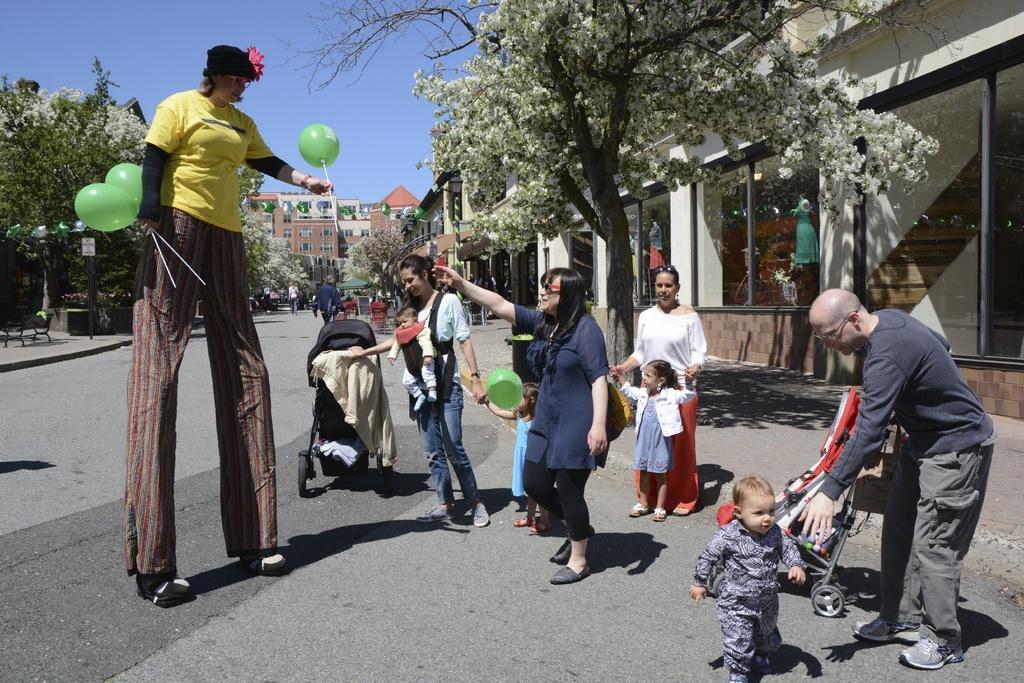In one or two sentences, can you explain what this image depicts? In this image I can see group of people, some are standing and some are walking and I can also see few balloons in green color, few strollers. In the background I can see few trees in green color, buildings and the sky is in blue color. 